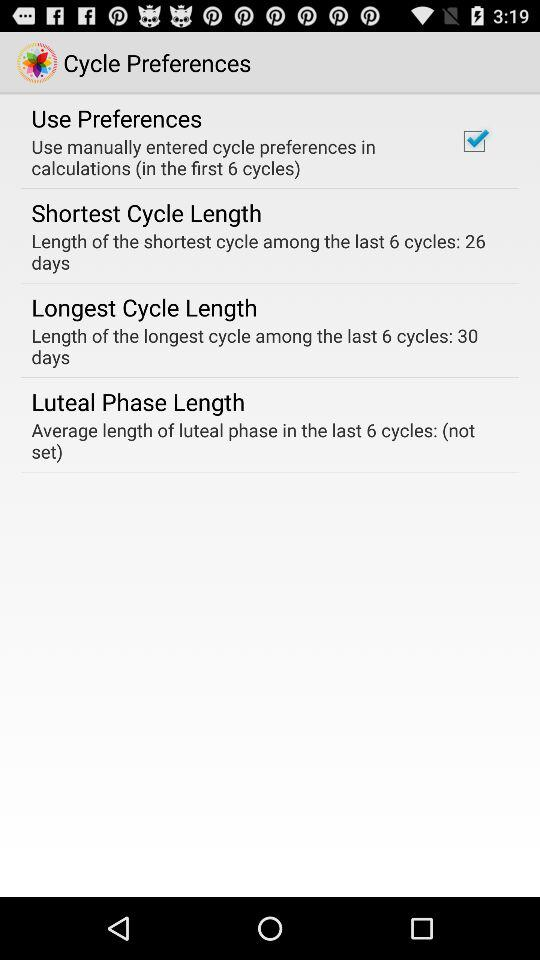What is the shortest cycle length? The shortest cycle length is 26 days. 